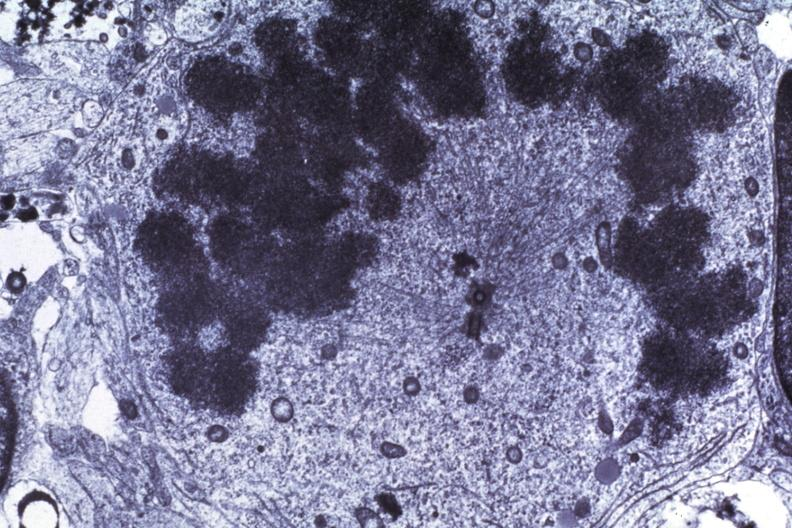what does this image show?
Answer the question using a single word or phrase. Dr garcia tumors 65 